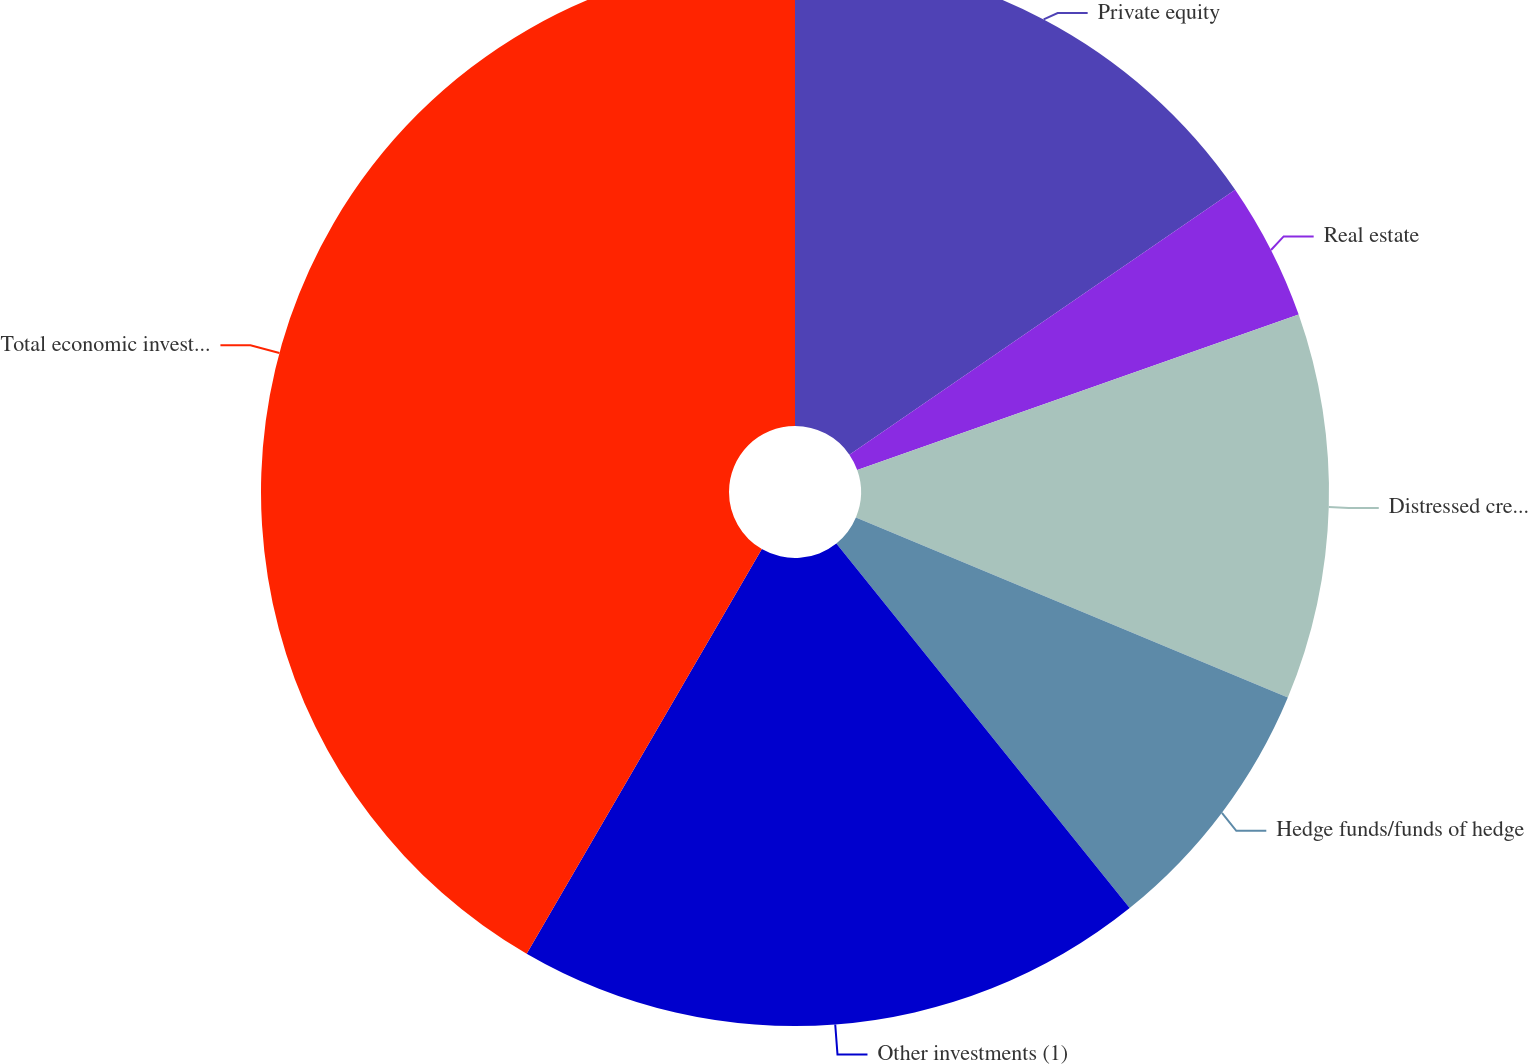Convert chart to OTSL. <chart><loc_0><loc_0><loc_500><loc_500><pie_chart><fcel>Private equity<fcel>Real estate<fcel>Distressed credit/mortgage<fcel>Hedge funds/funds of hedge<fcel>Other investments (1)<fcel>Total economic investment<nl><fcel>15.42%<fcel>4.19%<fcel>11.68%<fcel>7.93%<fcel>19.16%<fcel>41.62%<nl></chart> 